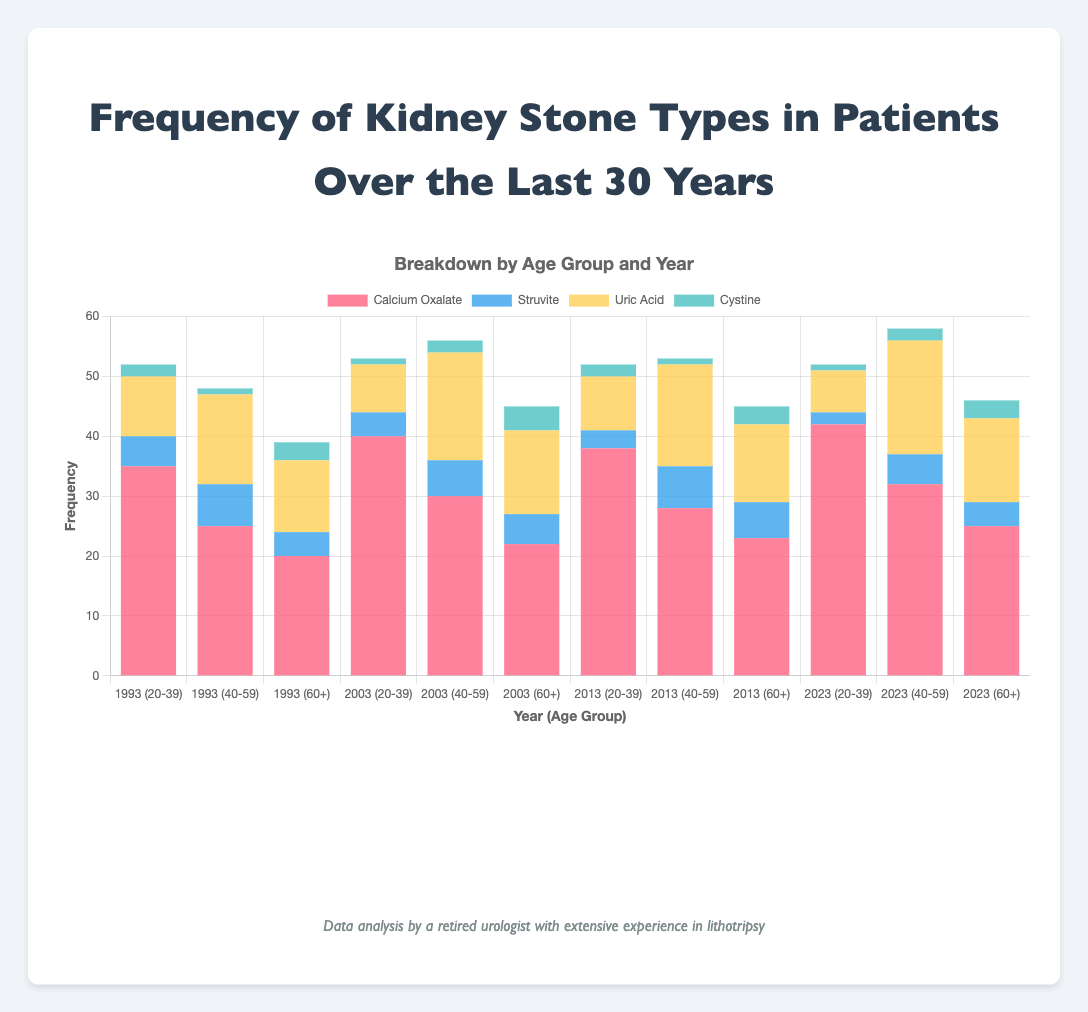What is the total number of Calcium Oxalate stones for the age group 20-39 across all years? To find the total, sum up the values of Calcium Oxalate stones for the age group 20-39 across all the years. These values are 35 (1993), 40 (2003), 38 (2013), and 42 (2023). Hence, 35 + 40 + 38 + 42 = 155.
Answer: 155 Which age group had the highest frequency of Uric Acid stones in 2023? Looking at the data for 2023, the frequency of Uric Acid stones for the age groups is as follows: 20-39 (7), 40-59 (19), and 60+ (14). The highest frequency is for the age group 40-59 with 19 stones.
Answer: 40-59 In which year did the age group 60+ have the lowest frequency of Struvite stones? Compare the frequency of Struvite stones in the age group 60+ across all the years. The values are 4 (1993), 5 (2003), 6 (2013), and 4 (2023). The lowest frequency (4) occurs in both 1993 and 2023.
Answer: 1993 and 2023 What is the average frequency of Cystine stones for the 40-59 age group across the years? To find the average, sum up the frequency values of Cystine stones for the age group 40-59 across the years: 1 (1993), 2 (2003), 1 (2013), and 2 (2023). Then, divide by the number of observations: (1 + 2 + 1 + 2) / 4 = 6 / 4 = 1.5.
Answer: 1.5 Which stone type had the most consistent frequency across all years for the age group 20-39? Observing the frequency values for each stone type in the age group 20-39 across all the years: Calcium Oxalate (35, 40, 38, 42), Struvite (5, 4, 3, 2), Uric Acid (10, 8, 9, 7), and Cystine (2, 1, 2, 1). Struvite and Cystine seem the most consistent in variation. Considering calculations and changes, Cystine has a smaller range of variation within 1 stone, making it the most consistent.
Answer: Cystine Compare the overall frequency of Uric Acid stones in the year 2013 between the age groups 20-39 and 60+. The frequencies of Uric Acid stones in 2013 are 9 for 20-39 and 13 for 60+. Comparing these, 60+ has a higher frequency than 20-39.
Answer: 60+ has higher What is the total number of stones in 2003 for the age group 60+? Sum up all types of stones (Calcium Oxalate, Struvite, Uric Acid, and Cystine) for the age group 60+ in 2003. The frequencies are: Calcium Oxalate (22), Struvite (5), Uric Acid (14), and Cystine (4). Hence, 22 + 5 + 14 + 4 = 45.
Answer: 45 